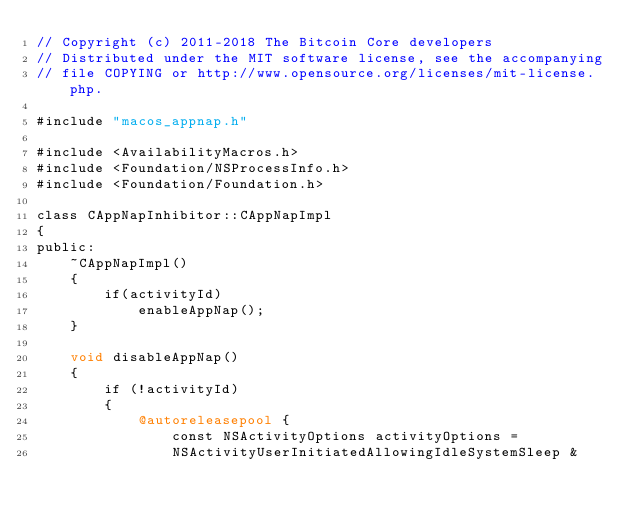<code> <loc_0><loc_0><loc_500><loc_500><_ObjectiveC_>// Copyright (c) 2011-2018 The Bitcoin Core developers
// Distributed under the MIT software license, see the accompanying
// file COPYING or http://www.opensource.org/licenses/mit-license.php.

#include "macos_appnap.h"

#include <AvailabilityMacros.h>
#include <Foundation/NSProcessInfo.h>
#include <Foundation/Foundation.h>

class CAppNapInhibitor::CAppNapImpl
{
public:
    ~CAppNapImpl()
    {
        if(activityId)
            enableAppNap();
    }

    void disableAppNap()
    {
        if (!activityId)
        {
            @autoreleasepool {
                const NSActivityOptions activityOptions =
                NSActivityUserInitiatedAllowingIdleSystemSleep &</code> 